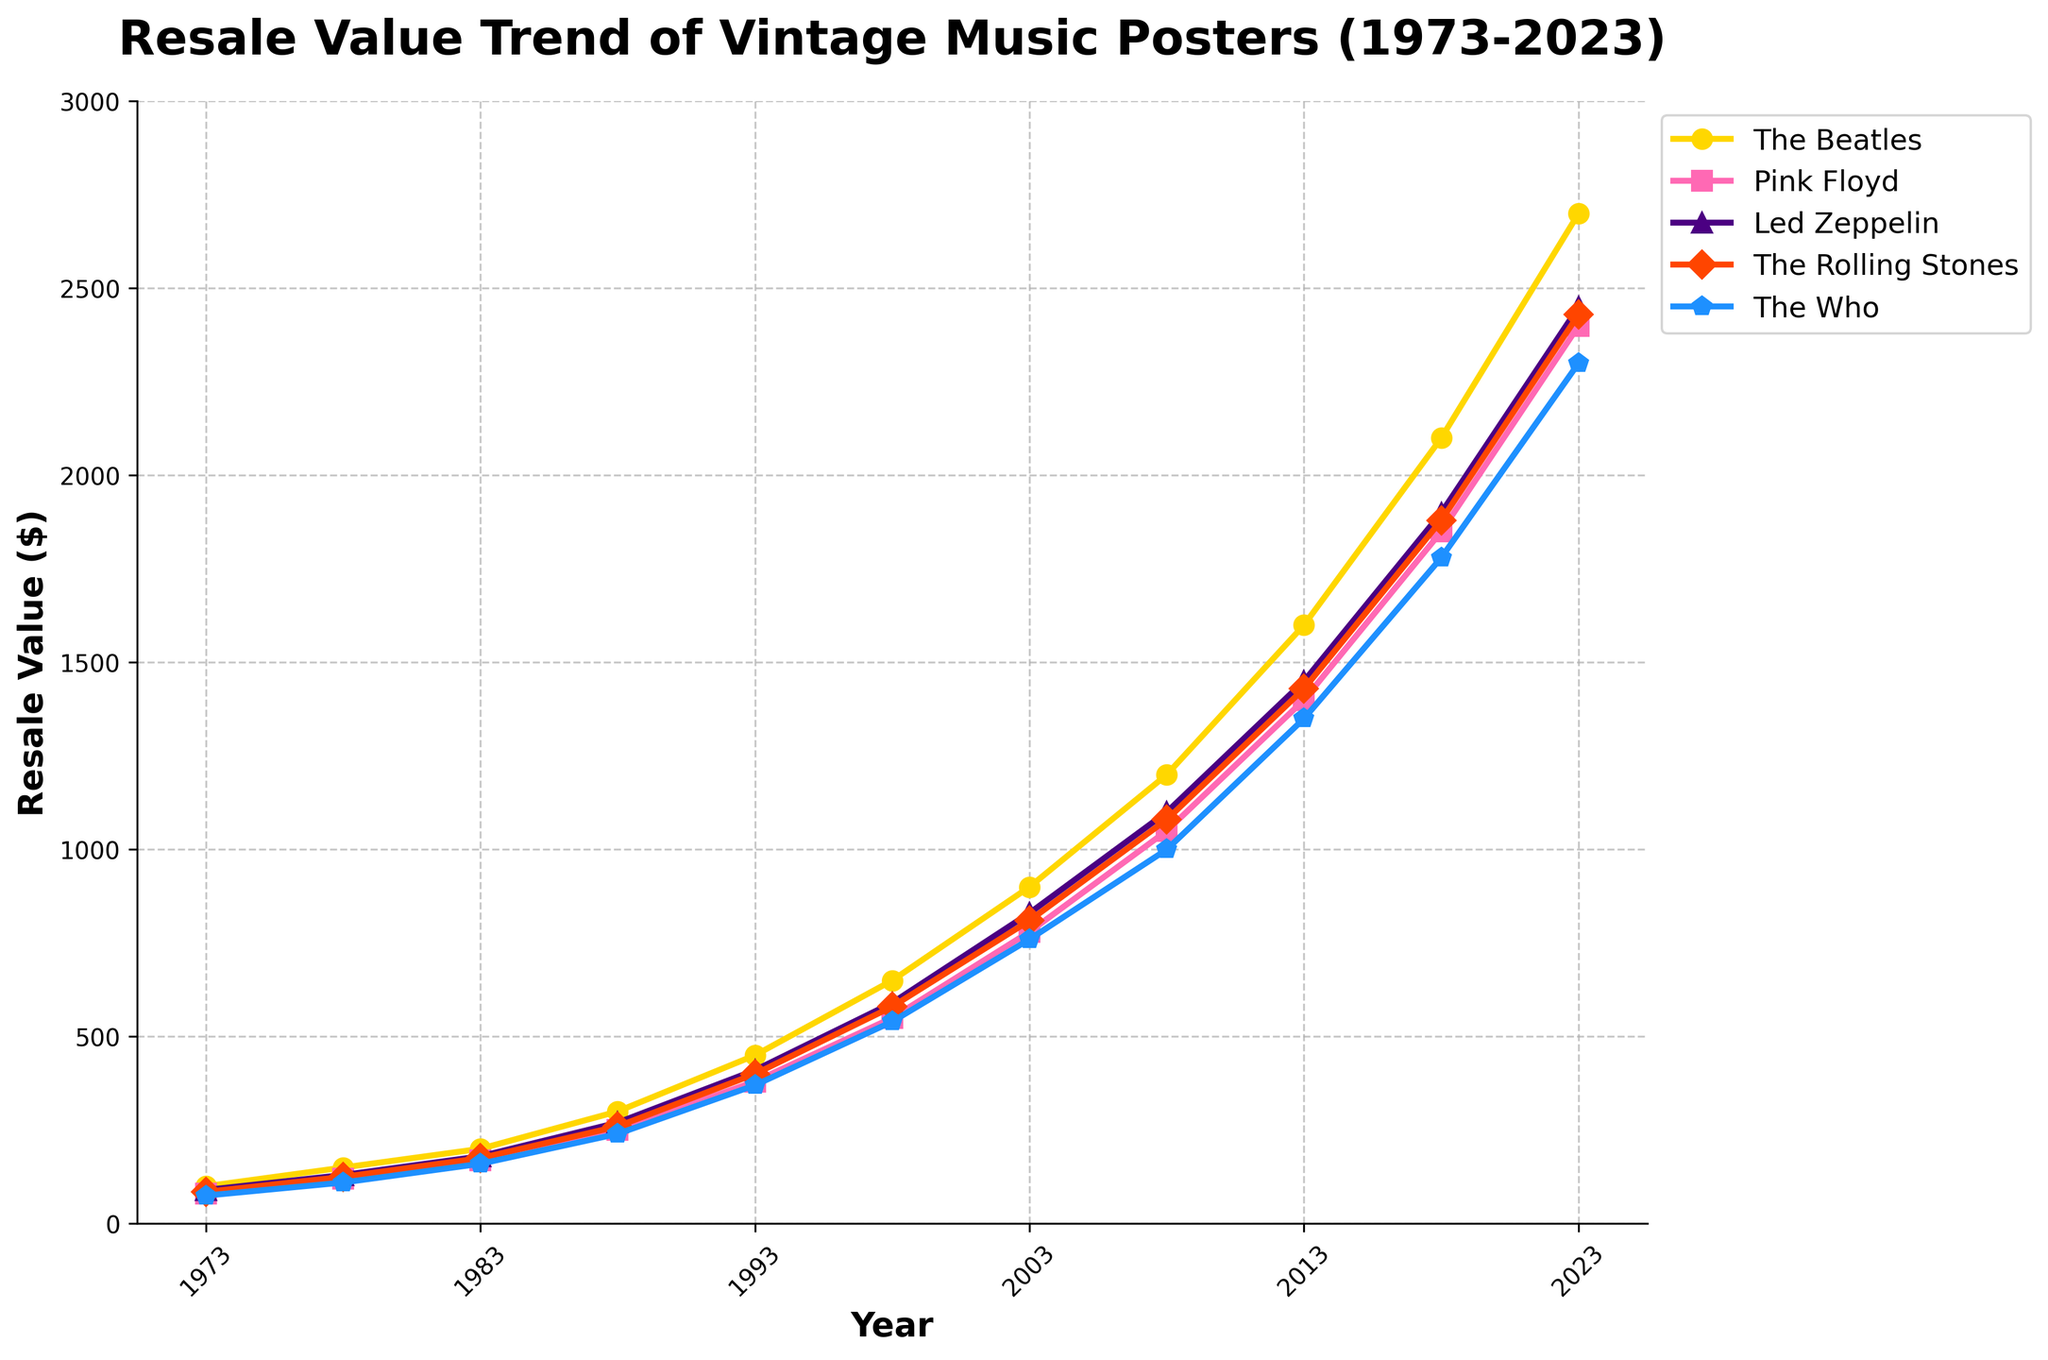What's the average resale value of The Beatles' posters in the first 10 years (1973-1983)? Look at the resale values of The Beatles' posters for 1973, 1978, and 1983. These are 100, 150, and 200 respectively. Add these values to get 450. Divide by the number of years (3) to get the average. Calculation: (100 + 150 + 200) / 3 = 450 / 3 = 150
Answer: 150 In which year did Pink Floyd's poster resale value surpass $1000? Look at the Pink Floyd series and find the year when the value first exceeds $1000. The value surpasses $1000 in 2008, where it's 1050.
Answer: 2008 Which band had the lowest resale value in 2023? Look at the values in the year 2023 for each band. The values are The Beatles (2700), Pink Floyd (2400), Led Zeppelin (2450), The Rolling Stones (2430), and The Who (2300). The lowest value is for The Who.
Answer: The Who How much did the resale value of The Rolling Stones' posters increase from 1973 to 2023? Subtract the 1973 value from the 2023 value for The Rolling Stones. The values are 85 in 1973 and 2430 in 2023. Calculation: 2430 - 85 = 2345
Answer: 2345 By how much did Led Zeppelin's resale value increase between 2008 and 2013? Look at the resale values of Led Zeppelin's posters in 2008 and 2013. These values are 1100 and 1450. Subtract the 2008 value from the 2013 value. Calculation: 1450 - 1100 = 350
Answer: 350 Which band's poster had the highest rate of increase in resale value between 1973 and 1983? Look at the resale values for each band between the years 1973 and 1983 and calculate the increase: The Beatles: 200 - 100 = 100, Pink Floyd: 170 - 80 = 90, Led Zeppelin: 180 - 90 = 90, The Rolling Stones: 175 - 85 = 90, The Who: 160 - 75 = 85. The highest rate of increase is by The Beatles with an increase of 100.
Answer: The Beatles In which year did The Who's poster resale value first surpass Pink Floyd's value in the same year? Compare the resale values of The Who and Pink Floyd for each year until The Who's value is greater than Pink Floyd's. It never does, as The Who’s values remain consistently lower.
Answer: Never How much more valuable were The Beatles' posters than The Rolling Stones’ in 2013? Subtract the 2013 value for The Rolling Stones from the 2013 value for The Beatles. The values are 1600 for The Beatles and 1430 for The Rolling Stones. Calculation: 1600 - 1430 = 170
Answer: 170 Which band's resale value showed the most consistent increase over the 50 years? Examining the lines in the chart, The Beatles' line appears to be the most steadily increasing without any sharp deviations or drops, indicating the most consistent increase.
Answer: The Beatles 